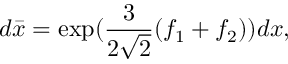Convert formula to latex. <formula><loc_0><loc_0><loc_500><loc_500>d \bar { x } = \exp ( \frac { 3 } { 2 \sqrt { 2 } } ( f _ { 1 } + f _ { 2 } ) ) d x ,</formula> 